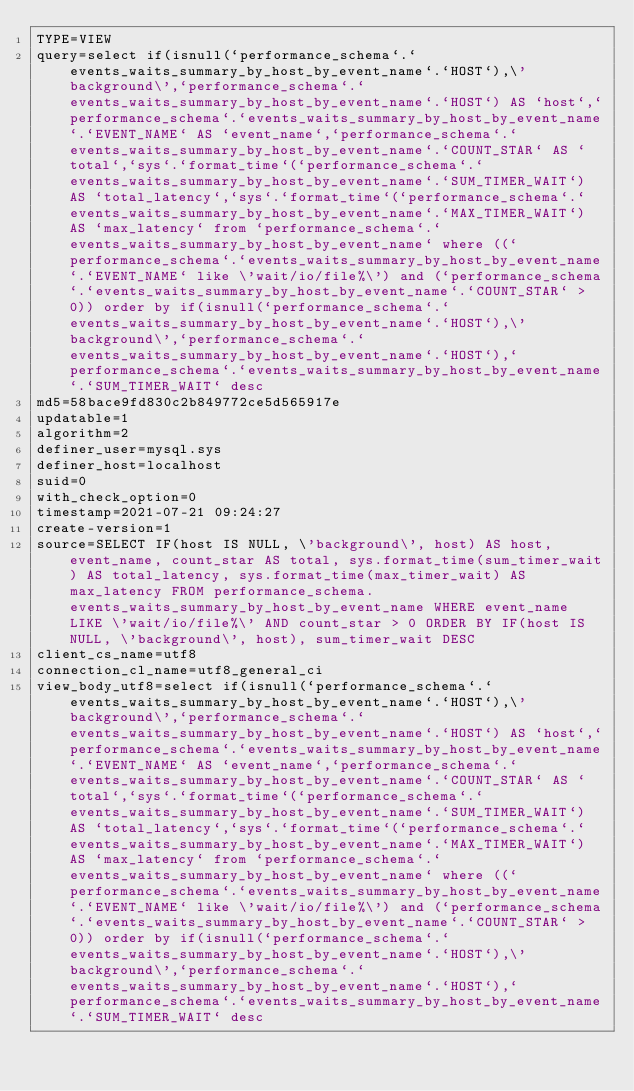Convert code to text. <code><loc_0><loc_0><loc_500><loc_500><_VisualBasic_>TYPE=VIEW
query=select if(isnull(`performance_schema`.`events_waits_summary_by_host_by_event_name`.`HOST`),\'background\',`performance_schema`.`events_waits_summary_by_host_by_event_name`.`HOST`) AS `host`,`performance_schema`.`events_waits_summary_by_host_by_event_name`.`EVENT_NAME` AS `event_name`,`performance_schema`.`events_waits_summary_by_host_by_event_name`.`COUNT_STAR` AS `total`,`sys`.`format_time`(`performance_schema`.`events_waits_summary_by_host_by_event_name`.`SUM_TIMER_WAIT`) AS `total_latency`,`sys`.`format_time`(`performance_schema`.`events_waits_summary_by_host_by_event_name`.`MAX_TIMER_WAIT`) AS `max_latency` from `performance_schema`.`events_waits_summary_by_host_by_event_name` where ((`performance_schema`.`events_waits_summary_by_host_by_event_name`.`EVENT_NAME` like \'wait/io/file%\') and (`performance_schema`.`events_waits_summary_by_host_by_event_name`.`COUNT_STAR` > 0)) order by if(isnull(`performance_schema`.`events_waits_summary_by_host_by_event_name`.`HOST`),\'background\',`performance_schema`.`events_waits_summary_by_host_by_event_name`.`HOST`),`performance_schema`.`events_waits_summary_by_host_by_event_name`.`SUM_TIMER_WAIT` desc
md5=58bace9fd830c2b849772ce5d565917e
updatable=1
algorithm=2
definer_user=mysql.sys
definer_host=localhost
suid=0
with_check_option=0
timestamp=2021-07-21 09:24:27
create-version=1
source=SELECT IF(host IS NULL, \'background\', host) AS host, event_name, count_star AS total, sys.format_time(sum_timer_wait) AS total_latency, sys.format_time(max_timer_wait) AS max_latency FROM performance_schema.events_waits_summary_by_host_by_event_name WHERE event_name LIKE \'wait/io/file%\' AND count_star > 0 ORDER BY IF(host IS NULL, \'background\', host), sum_timer_wait DESC
client_cs_name=utf8
connection_cl_name=utf8_general_ci
view_body_utf8=select if(isnull(`performance_schema`.`events_waits_summary_by_host_by_event_name`.`HOST`),\'background\',`performance_schema`.`events_waits_summary_by_host_by_event_name`.`HOST`) AS `host`,`performance_schema`.`events_waits_summary_by_host_by_event_name`.`EVENT_NAME` AS `event_name`,`performance_schema`.`events_waits_summary_by_host_by_event_name`.`COUNT_STAR` AS `total`,`sys`.`format_time`(`performance_schema`.`events_waits_summary_by_host_by_event_name`.`SUM_TIMER_WAIT`) AS `total_latency`,`sys`.`format_time`(`performance_schema`.`events_waits_summary_by_host_by_event_name`.`MAX_TIMER_WAIT`) AS `max_latency` from `performance_schema`.`events_waits_summary_by_host_by_event_name` where ((`performance_schema`.`events_waits_summary_by_host_by_event_name`.`EVENT_NAME` like \'wait/io/file%\') and (`performance_schema`.`events_waits_summary_by_host_by_event_name`.`COUNT_STAR` > 0)) order by if(isnull(`performance_schema`.`events_waits_summary_by_host_by_event_name`.`HOST`),\'background\',`performance_schema`.`events_waits_summary_by_host_by_event_name`.`HOST`),`performance_schema`.`events_waits_summary_by_host_by_event_name`.`SUM_TIMER_WAIT` desc
</code> 